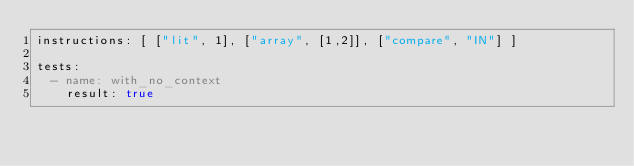<code> <loc_0><loc_0><loc_500><loc_500><_YAML_>instructions: [ ["lit", 1], ["array", [1,2]], ["compare", "IN"] ]

tests:
  - name: with_no_context
    result: true
</code> 